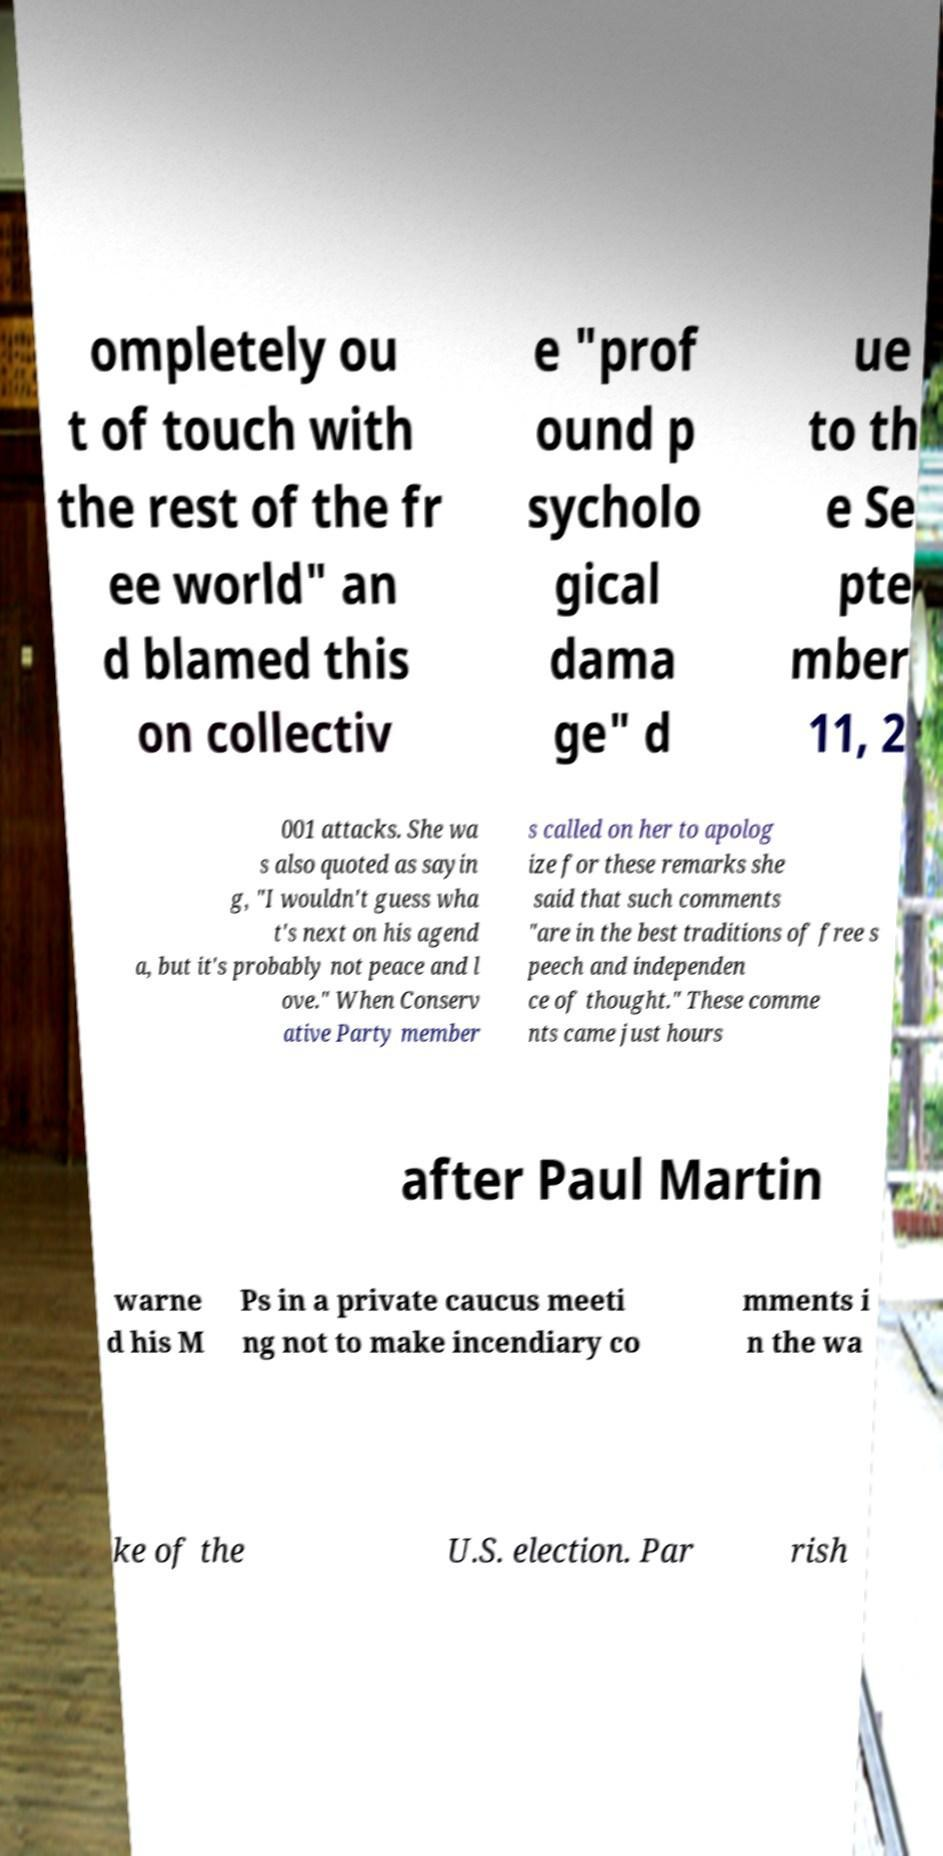Please read and relay the text visible in this image. What does it say? ompletely ou t of touch with the rest of the fr ee world" an d blamed this on collectiv e "prof ound p sycholo gical dama ge" d ue to th e Se pte mber 11, 2 001 attacks. She wa s also quoted as sayin g, "I wouldn't guess wha t's next on his agend a, but it's probably not peace and l ove." When Conserv ative Party member s called on her to apolog ize for these remarks she said that such comments "are in the best traditions of free s peech and independen ce of thought." These comme nts came just hours after Paul Martin warne d his M Ps in a private caucus meeti ng not to make incendiary co mments i n the wa ke of the U.S. election. Par rish 